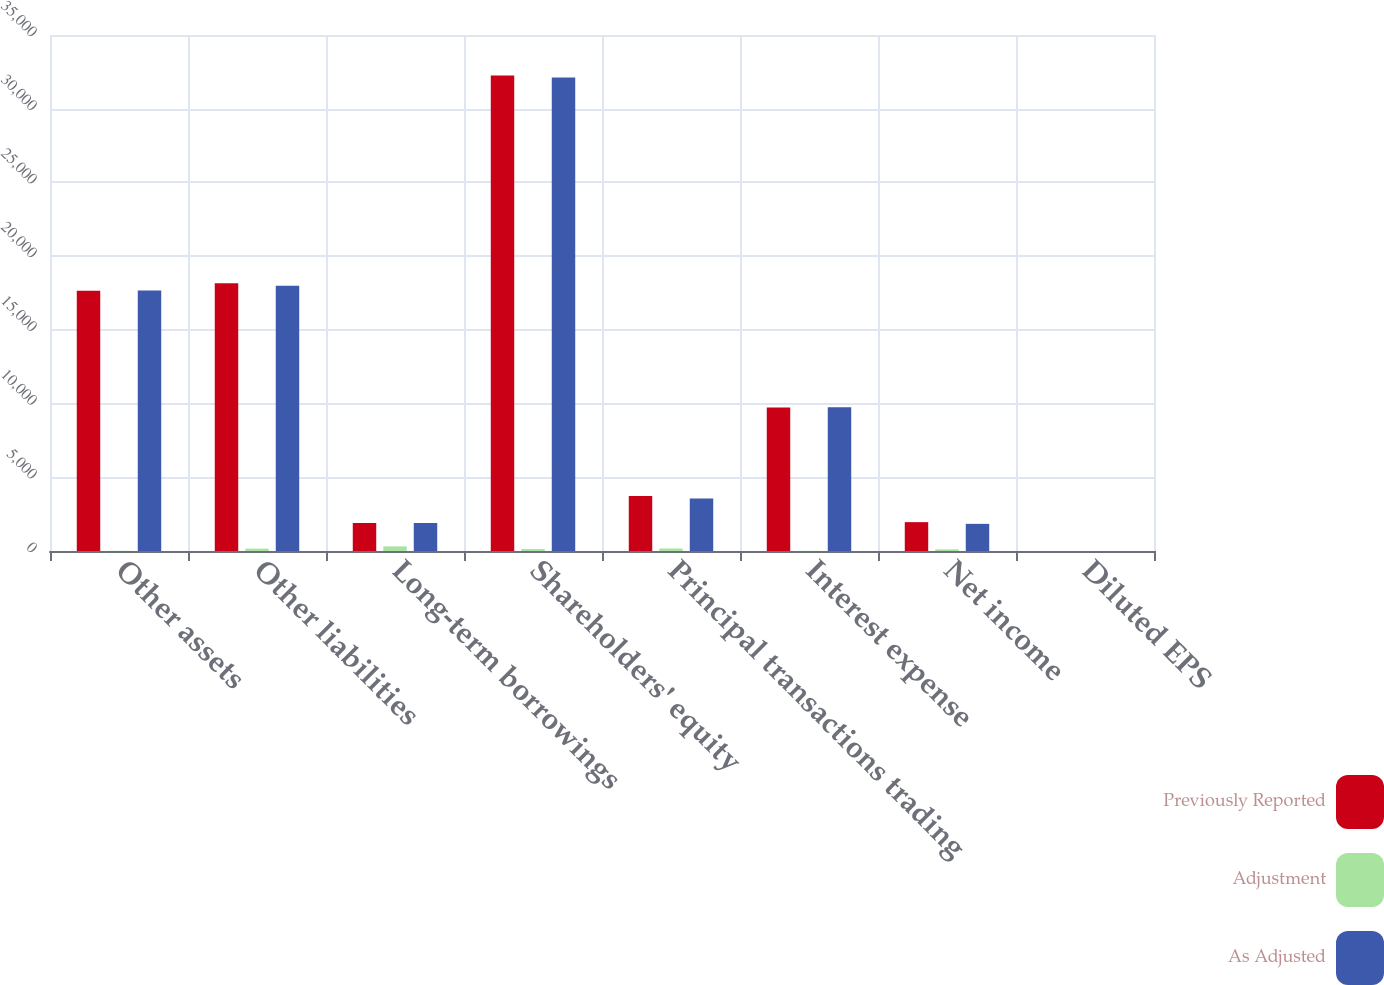Convert chart to OTSL. <chart><loc_0><loc_0><loc_500><loc_500><stacked_bar_chart><ecel><fcel>Other assets<fcel>Other liabilities<fcel>Long-term borrowings<fcel>Shareholders' equity<fcel>Principal transactions trading<fcel>Interest expense<fcel>Net income<fcel>Diluted EPS<nl><fcel>Previously Reported<fcel>17651<fcel>18159<fcel>1899<fcel>32255<fcel>3729<fcel>9735<fcel>1957<fcel>1.86<nl><fcel>Adjustment<fcel>12<fcel>162<fcel>311<fcel>137<fcel>170<fcel>9<fcel>116<fcel>0.11<nl><fcel>As Adjusted<fcel>17663<fcel>17997<fcel>1899<fcel>32118<fcel>3559<fcel>9744<fcel>1841<fcel>1.75<nl></chart> 